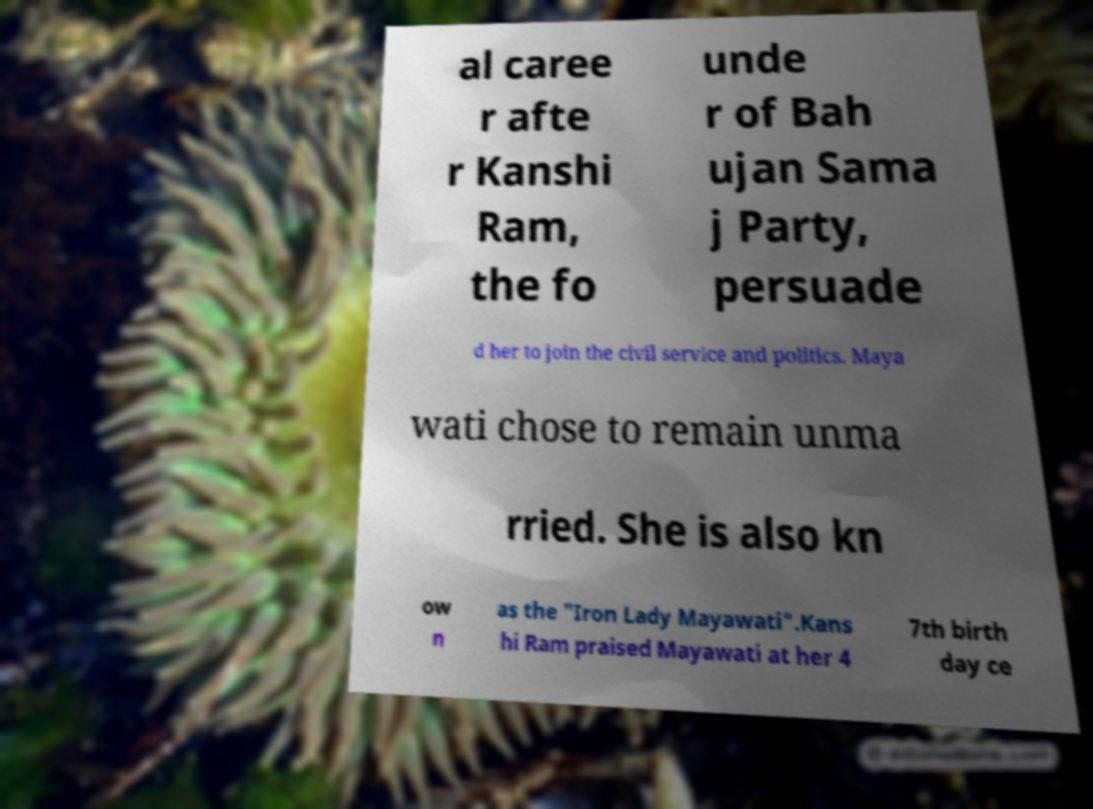There's text embedded in this image that I need extracted. Can you transcribe it verbatim? al caree r afte r Kanshi Ram, the fo unde r of Bah ujan Sama j Party, persuade d her to join the civil service and politics. Maya wati chose to remain unma rried. She is also kn ow n as the "Iron Lady Mayawati".Kans hi Ram praised Mayawati at her 4 7th birth day ce 